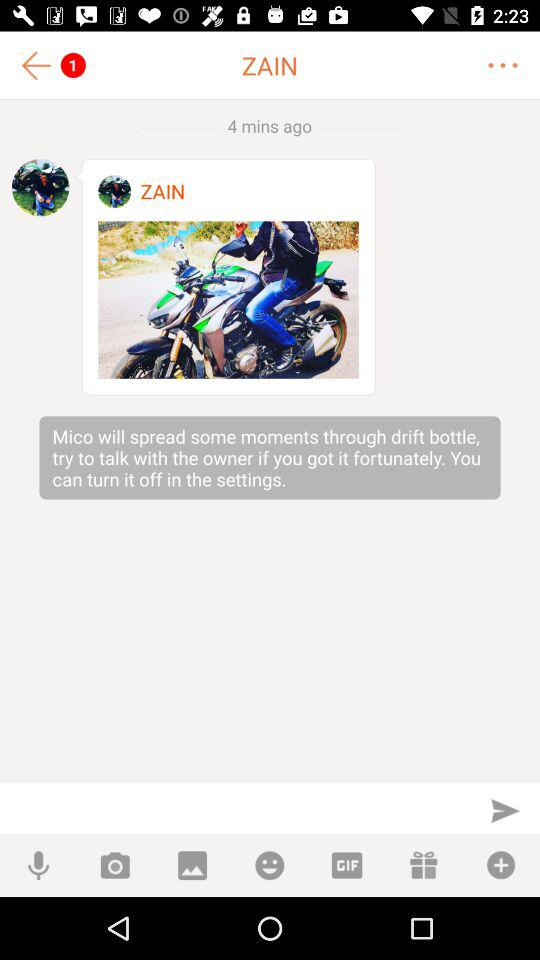How many pending messages are there? There is 1 pending message. 